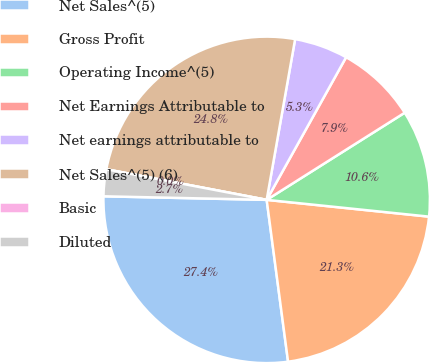<chart> <loc_0><loc_0><loc_500><loc_500><pie_chart><fcel>Net Sales^(5)<fcel>Gross Profit<fcel>Operating Income^(5)<fcel>Net Earnings Attributable to<fcel>Net earnings attributable to<fcel>Net Sales^(5) (6)<fcel>Basic<fcel>Diluted<nl><fcel>27.44%<fcel>21.27%<fcel>10.6%<fcel>7.95%<fcel>5.3%<fcel>24.79%<fcel>0.0%<fcel>2.65%<nl></chart> 